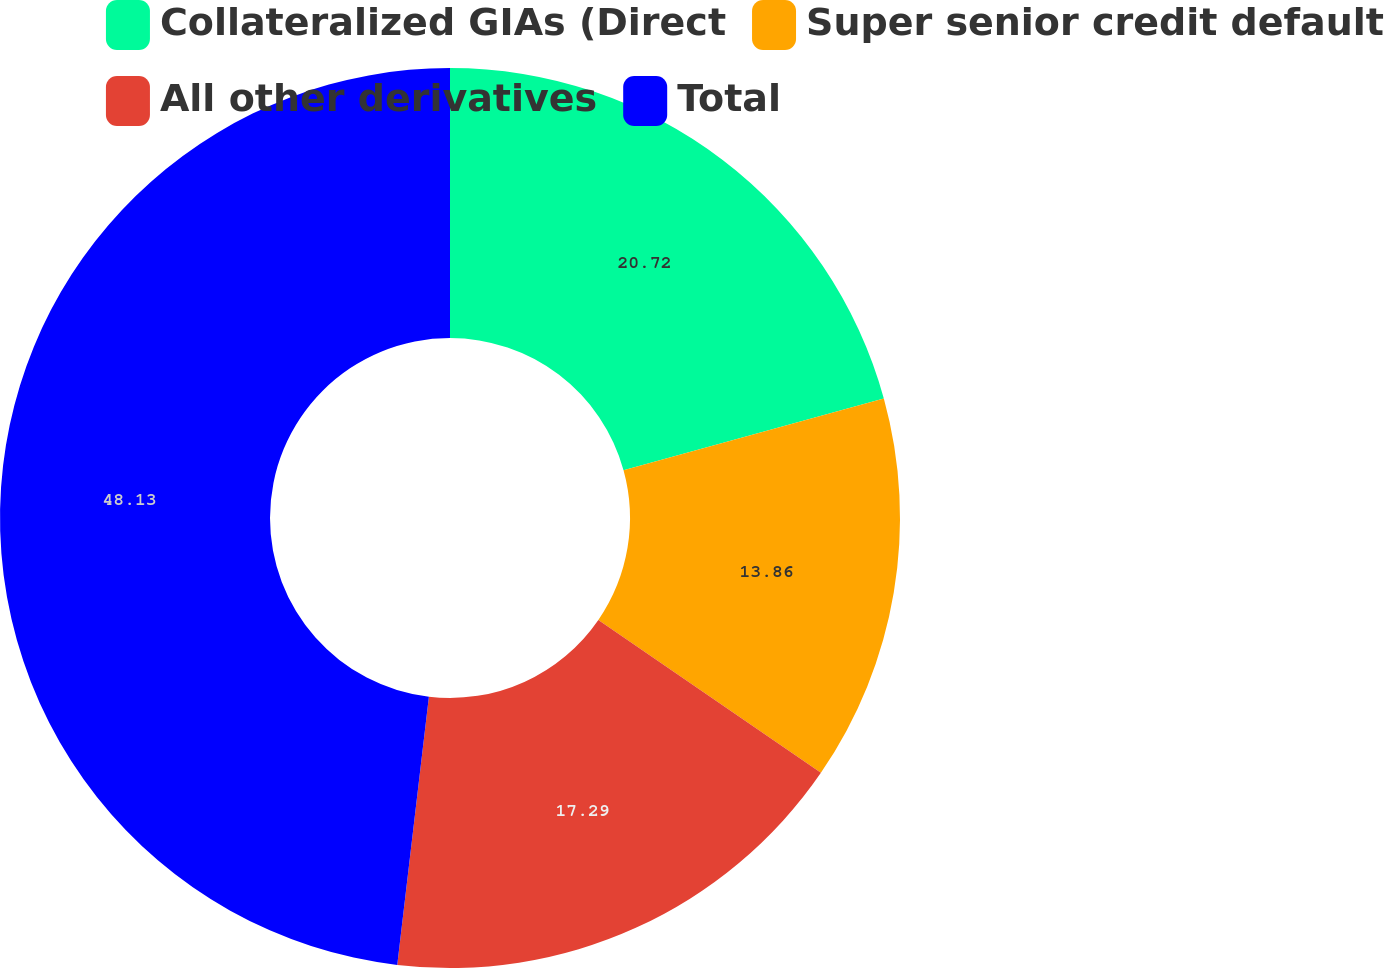Convert chart. <chart><loc_0><loc_0><loc_500><loc_500><pie_chart><fcel>Collateralized GIAs (Direct<fcel>Super senior credit default<fcel>All other derivatives<fcel>Total<nl><fcel>20.72%<fcel>13.86%<fcel>17.29%<fcel>48.13%<nl></chart> 